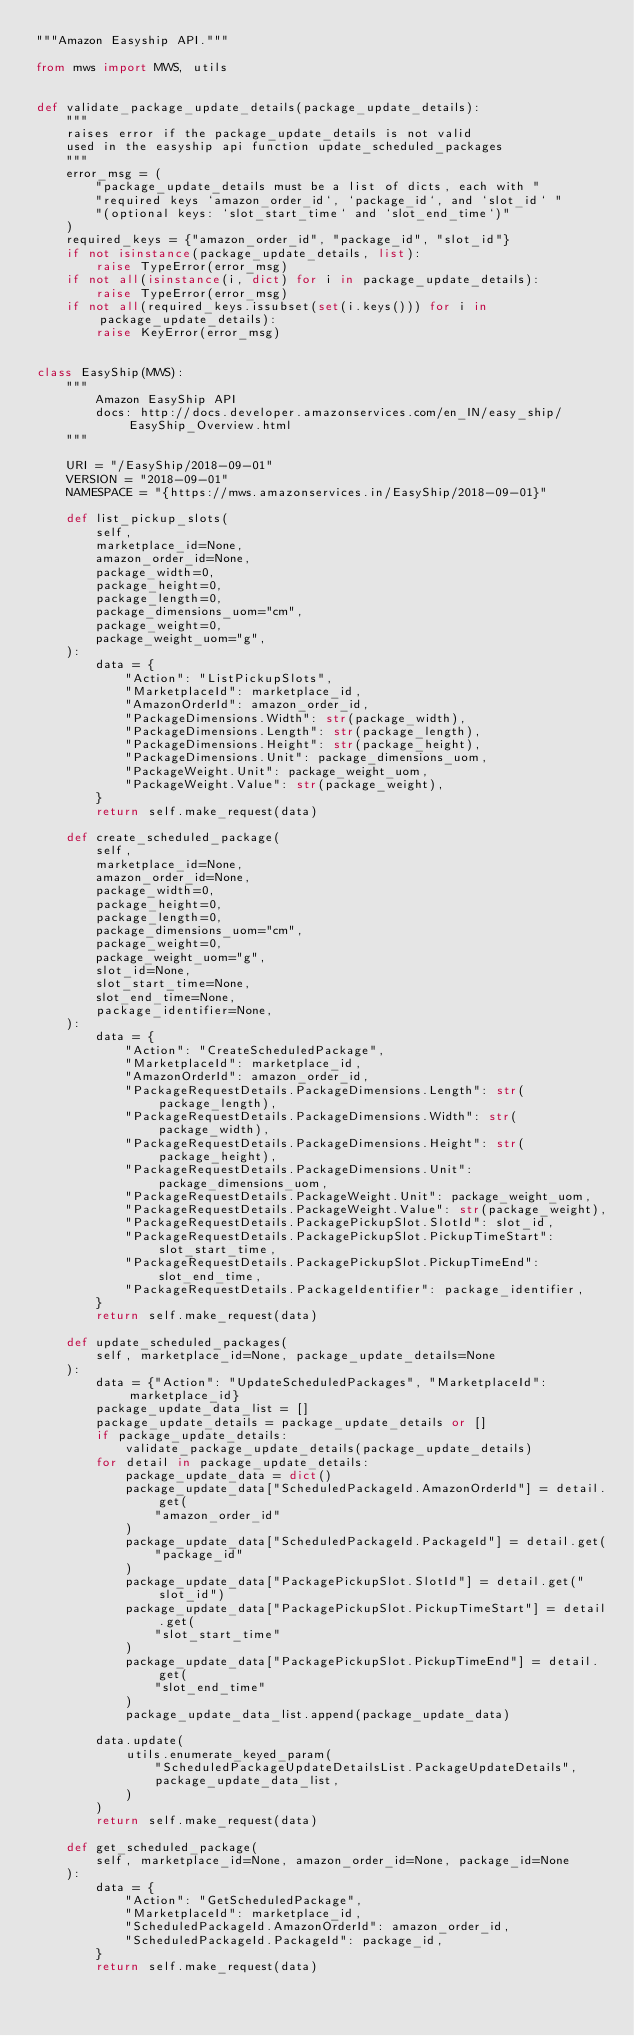Convert code to text. <code><loc_0><loc_0><loc_500><loc_500><_Python_>"""Amazon Easyship API."""

from mws import MWS, utils


def validate_package_update_details(package_update_details):
    """
    raises error if the package_update_details is not valid
    used in the easyship api function update_scheduled_packages
    """
    error_msg = (
        "package_update_details must be a list of dicts, each with "
        "required keys `amazon_order_id`, `package_id`, and `slot_id` "
        "(optional keys: `slot_start_time` and `slot_end_time`)"
    )
    required_keys = {"amazon_order_id", "package_id", "slot_id"}
    if not isinstance(package_update_details, list):
        raise TypeError(error_msg)
    if not all(isinstance(i, dict) for i in package_update_details):
        raise TypeError(error_msg)
    if not all(required_keys.issubset(set(i.keys())) for i in package_update_details):
        raise KeyError(error_msg)


class EasyShip(MWS):
    """
        Amazon EasyShip API
        docs: http://docs.developer.amazonservices.com/en_IN/easy_ship/EasyShip_Overview.html
    """

    URI = "/EasyShip/2018-09-01"
    VERSION = "2018-09-01"
    NAMESPACE = "{https://mws.amazonservices.in/EasyShip/2018-09-01}"

    def list_pickup_slots(
        self,
        marketplace_id=None,
        amazon_order_id=None,
        package_width=0,
        package_height=0,
        package_length=0,
        package_dimensions_uom="cm",
        package_weight=0,
        package_weight_uom="g",
    ):
        data = {
            "Action": "ListPickupSlots",
            "MarketplaceId": marketplace_id,
            "AmazonOrderId": amazon_order_id,
            "PackageDimensions.Width": str(package_width),
            "PackageDimensions.Length": str(package_length),
            "PackageDimensions.Height": str(package_height),
            "PackageDimensions.Unit": package_dimensions_uom,
            "PackageWeight.Unit": package_weight_uom,
            "PackageWeight.Value": str(package_weight),
        }
        return self.make_request(data)

    def create_scheduled_package(
        self,
        marketplace_id=None,
        amazon_order_id=None,
        package_width=0,
        package_height=0,
        package_length=0,
        package_dimensions_uom="cm",
        package_weight=0,
        package_weight_uom="g",
        slot_id=None,
        slot_start_time=None,
        slot_end_time=None,
        package_identifier=None,
    ):
        data = {
            "Action": "CreateScheduledPackage",
            "MarketplaceId": marketplace_id,
            "AmazonOrderId": amazon_order_id,
            "PackageRequestDetails.PackageDimensions.Length": str(package_length),
            "PackageRequestDetails.PackageDimensions.Width": str(package_width),
            "PackageRequestDetails.PackageDimensions.Height": str(package_height),
            "PackageRequestDetails.PackageDimensions.Unit": package_dimensions_uom,
            "PackageRequestDetails.PackageWeight.Unit": package_weight_uom,
            "PackageRequestDetails.PackageWeight.Value": str(package_weight),
            "PackageRequestDetails.PackagePickupSlot.SlotId": slot_id,
            "PackageRequestDetails.PackagePickupSlot.PickupTimeStart": slot_start_time,
            "PackageRequestDetails.PackagePickupSlot.PickupTimeEnd": slot_end_time,
            "PackageRequestDetails.PackageIdentifier": package_identifier,
        }
        return self.make_request(data)

    def update_scheduled_packages(
        self, marketplace_id=None, package_update_details=None
    ):
        data = {"Action": "UpdateScheduledPackages", "MarketplaceId": marketplace_id}
        package_update_data_list = []
        package_update_details = package_update_details or []
        if package_update_details:
            validate_package_update_details(package_update_details)
        for detail in package_update_details:
            package_update_data = dict()
            package_update_data["ScheduledPackageId.AmazonOrderId"] = detail.get(
                "amazon_order_id"
            )
            package_update_data["ScheduledPackageId.PackageId"] = detail.get(
                "package_id"
            )
            package_update_data["PackagePickupSlot.SlotId"] = detail.get("slot_id")
            package_update_data["PackagePickupSlot.PickupTimeStart"] = detail.get(
                "slot_start_time"
            )
            package_update_data["PackagePickupSlot.PickupTimeEnd"] = detail.get(
                "slot_end_time"
            )
            package_update_data_list.append(package_update_data)

        data.update(
            utils.enumerate_keyed_param(
                "ScheduledPackageUpdateDetailsList.PackageUpdateDetails",
                package_update_data_list,
            )
        )
        return self.make_request(data)

    def get_scheduled_package(
        self, marketplace_id=None, amazon_order_id=None, package_id=None
    ):
        data = {
            "Action": "GetScheduledPackage",
            "MarketplaceId": marketplace_id,
            "ScheduledPackageId.AmazonOrderId": amazon_order_id,
            "ScheduledPackageId.PackageId": package_id,
        }
        return self.make_request(data)
</code> 